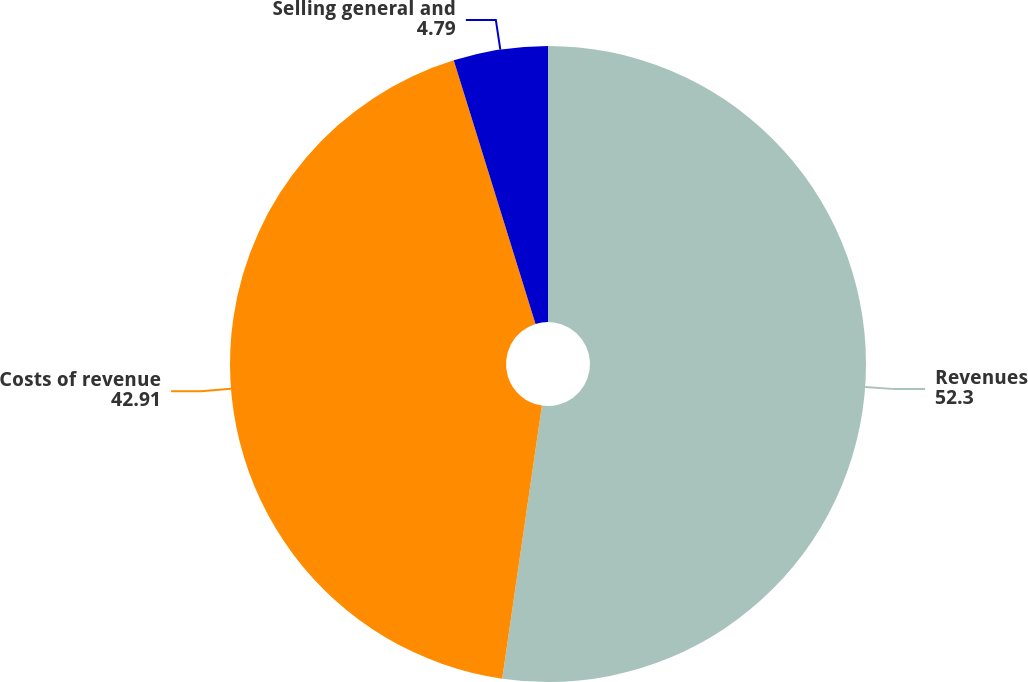Convert chart to OTSL. <chart><loc_0><loc_0><loc_500><loc_500><pie_chart><fcel>Revenues<fcel>Costs of revenue<fcel>Selling general and<nl><fcel>52.3%<fcel>42.91%<fcel>4.79%<nl></chart> 